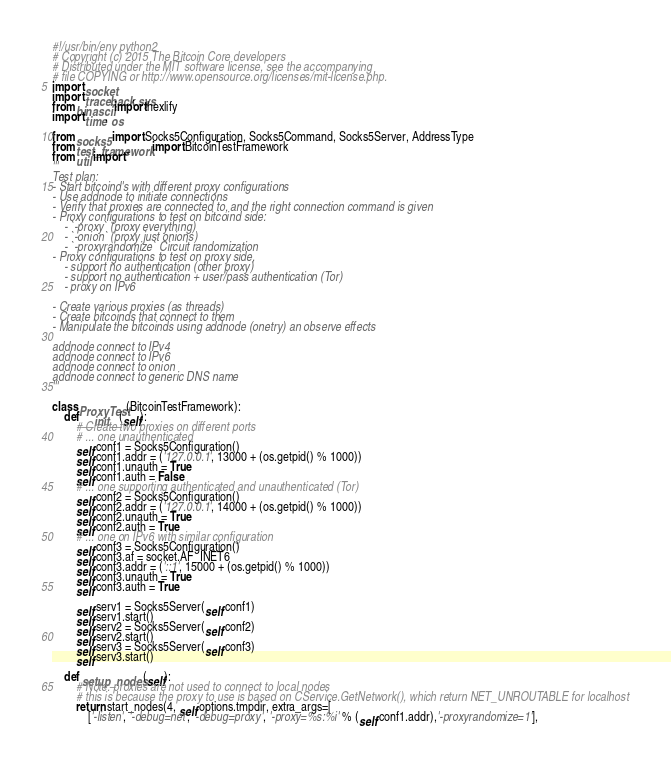Convert code to text. <code><loc_0><loc_0><loc_500><loc_500><_Python_>#!/usr/bin/env python2
# Copyright (c) 2015 The Bitcoin Core developers
# Distributed under the MIT software license, see the accompanying
# file COPYING or http://www.opensource.org/licenses/mit-license.php.
import socket
import traceback, sys
from binascii import hexlify
import time, os

from socks5 import Socks5Configuration, Socks5Command, Socks5Server, AddressType
from test_framework import BitcoinTestFramework
from util import *
'''
Test plan:
- Start bitcoind's with different proxy configurations
- Use addnode to initiate connections
- Verify that proxies are connected to, and the right connection command is given
- Proxy configurations to test on bitcoind side:
    - `-proxy` (proxy everything)
    - `-onion` (proxy just onions)
    - `-proxyrandomize` Circuit randomization
- Proxy configurations to test on proxy side,
    - support no authentication (other proxy)
    - support no authentication + user/pass authentication (Tor)
    - proxy on IPv6

- Create various proxies (as threads)
- Create bitcoinds that connect to them
- Manipulate the bitcoinds using addnode (onetry) an observe effects

addnode connect to IPv4
addnode connect to IPv6
addnode connect to onion
addnode connect to generic DNS name
'''

class ProxyTest(BitcoinTestFramework):
    def __init__(self):
        # Create two proxies on different ports
        # ... one unauthenticated
        self.conf1 = Socks5Configuration()
        self.conf1.addr = ('127.0.0.1', 13000 + (os.getpid() % 1000))
        self.conf1.unauth = True
        self.conf1.auth = False
        # ... one supporting authenticated and unauthenticated (Tor)
        self.conf2 = Socks5Configuration()
        self.conf2.addr = ('127.0.0.1', 14000 + (os.getpid() % 1000))
        self.conf2.unauth = True
        self.conf2.auth = True
        # ... one on IPv6 with similar configuration
        self.conf3 = Socks5Configuration()
        self.conf3.af = socket.AF_INET6
        self.conf3.addr = ('::1', 15000 + (os.getpid() % 1000))
        self.conf3.unauth = True
        self.conf3.auth = True

        self.serv1 = Socks5Server(self.conf1)
        self.serv1.start()
        self.serv2 = Socks5Server(self.conf2)
        self.serv2.start()
        self.serv3 = Socks5Server(self.conf3)
        self.serv3.start()

    def setup_nodes(self):
        # Note: proxies are not used to connect to local nodes
        # this is because the proxy to use is based on CService.GetNetwork(), which return NET_UNROUTABLE for localhost
        return start_nodes(4, self.options.tmpdir, extra_args=[
            ['-listen', '-debug=net', '-debug=proxy', '-proxy=%s:%i' % (self.conf1.addr),'-proxyrandomize=1'],</code> 